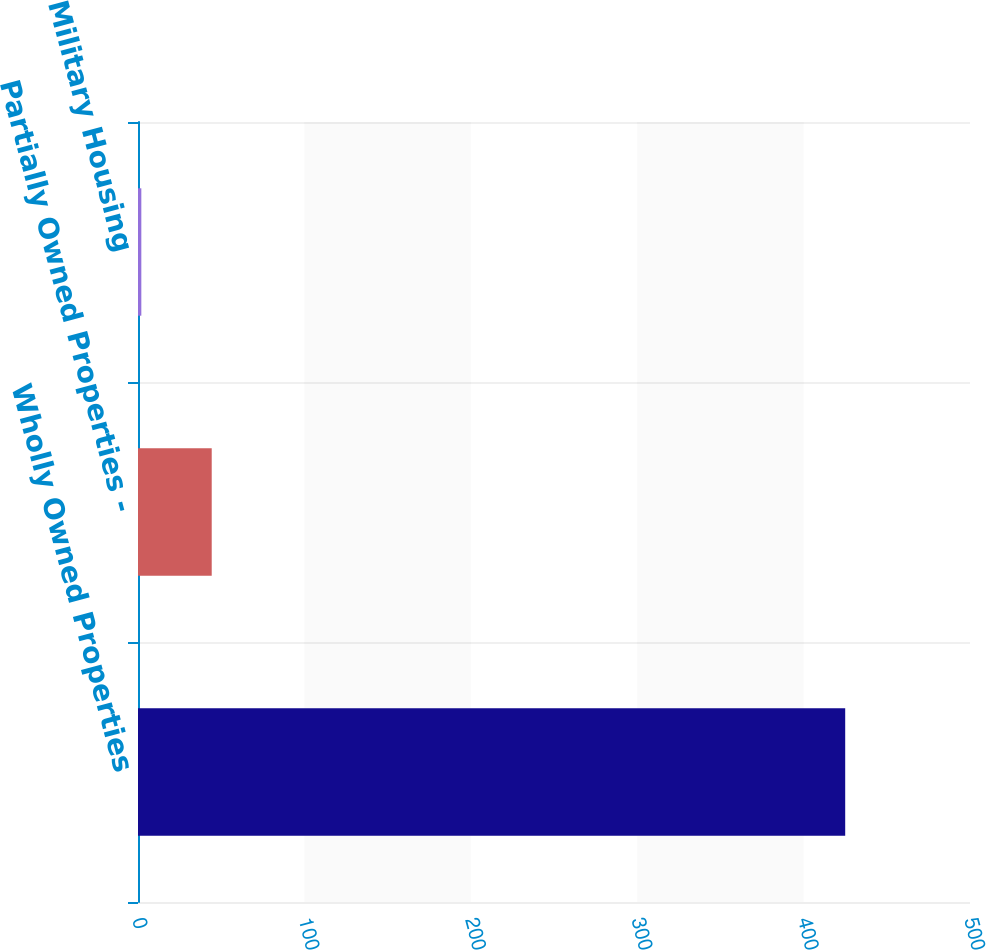Convert chart. <chart><loc_0><loc_0><loc_500><loc_500><bar_chart><fcel>Wholly Owned Properties<fcel>Partially Owned Properties -<fcel>Military Housing<nl><fcel>425<fcel>44.3<fcel>2<nl></chart> 